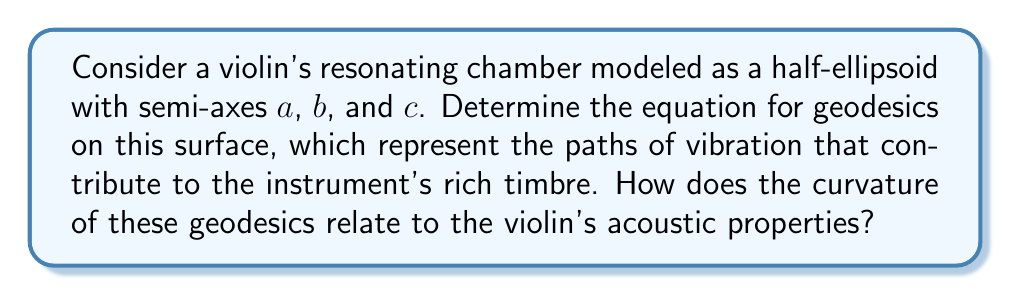Could you help me with this problem? Let's approach this step-by-step:

1) The surface of a half-ellipsoid can be parameterized as:
   $$\mathbf{r}(u,v) = (a\cos u \cos v, b\sin u \cos v, c\sin v)$$
   where $0 \leq u < 2\pi$ and $0 \leq v \leq \frac{\pi}{2}$

2) To find the geodesics, we need to compute the first fundamental form. The components are:
   $$E = \left(\frac{\partial \mathbf{r}}{\partial u}\right)^2 = a^2\cos^2 v \sin^2 u + b^2\cos^2 v \cos^2 u$$
   $$F = \frac{\partial \mathbf{r}}{\partial u} \cdot \frac{\partial \mathbf{r}}{\partial v} = (b^2-a^2)\cos v \sin u \cos u \sin v$$
   $$G = \left(\frac{\partial \mathbf{r}}{\partial v}\right)^2 = (a^2\cos^2 u + b^2\sin^2 u)\sin^2 v + c^2\cos^2 v$$

3) The geodesic equations are given by:
   $$\frac{d^2u}{ds^2} + \Gamma^u_{uu}\left(\frac{du}{ds}\right)^2 + 2\Gamma^u_{uv}\frac{du}{ds}\frac{dv}{ds} + \Gamma^u_{vv}\left(\frac{dv}{ds}\right)^2 = 0$$
   $$\frac{d^2v}{ds^2} + \Gamma^v_{uu}\left(\frac{du}{ds}\right)^2 + 2\Gamma^v_{uv}\frac{du}{ds}\frac{dv}{ds} + \Gamma^v_{vv}\left(\frac{dv}{ds}\right)^2 = 0$$

   where $\Gamma^i_{jk}$ are the Christoffel symbols.

4) The Christoffel symbols can be calculated using the components of the first fundamental form. The resulting equations are complex and typically solved numerically.

5) The curvature of these geodesics is related to the Gaussian curvature of the surface:
   $$K = \frac{c^2}{(a^2\sin^2 v + b^2\cos^2 v)^2\cos^2 v + c^2(a^2\cos^2 u + b^2\sin^2 u)\sin^2 v}$$

6) The curvature of the geodesics affects the violin's acoustic properties by influencing how vibrations travel along the surface. Areas of high curvature tend to scatter vibrations, while areas of low curvature allow vibrations to travel more freely.

7) The relationship between geodesic curvature and sound can be understood through the wave equation on curved surfaces:
   $$\frac{\partial^2 \psi}{\partial t^2} = c^2 \Delta_g \psi$$
   where $\Delta_g$ is the Laplace-Beltrami operator, which depends on the surface's metric.

8) The solutions to this equation, influenced by the geodesics, determine the resonant frequencies and modes of the violin, contributing to its unique timbre.
Answer: Geodesics satisfy complex differential equations involving Christoffel symbols. Their curvature, related to the surface's Gaussian curvature, influences sound propagation and the violin's acoustic properties. 